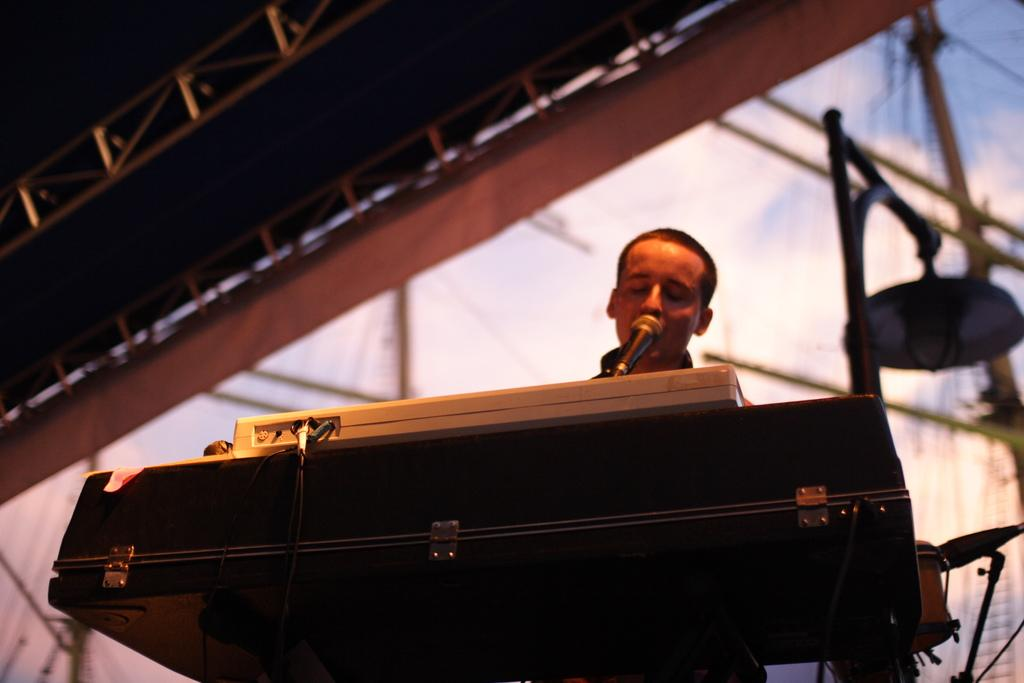What is the man in the image doing? The man is standing in the image. What is in front of the man? There is a musical instrument and a microphone (mic) in front of the man. What type of musical instrument is in front of the man? The provided facts do not specify the type of musical instrument. What can be seen at the top of the image? There are steel objects visible at the top of the image. What is located on the right side of the image? There are drums on the right side of the image. What type of dog is playing with the property in the image? There is no dog or property present in the image. What activity is the man participating in with the other people in the image? The provided facts do not mention any other people in the image, so we cannot determine if the man is participating in an activity with others. 